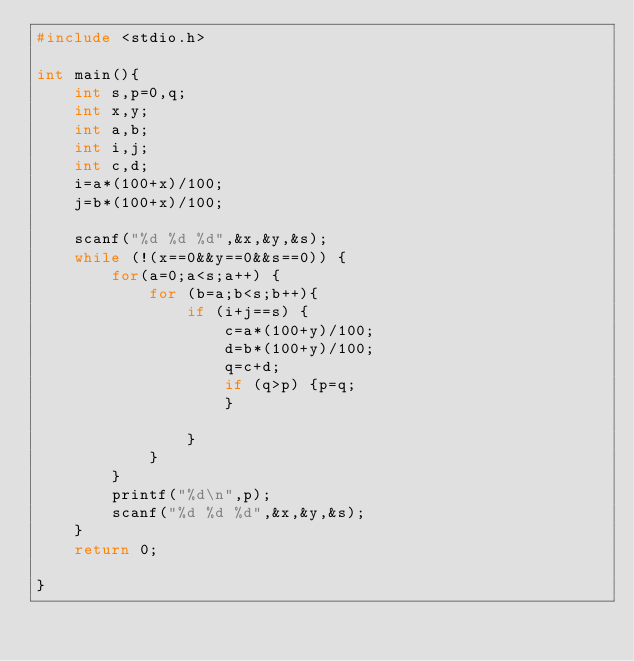<code> <loc_0><loc_0><loc_500><loc_500><_C_>#include <stdio.h>

int main(){
    int s,p=0,q;
    int x,y;
    int a,b;
    int i,j;
    int c,d;
    i=a*(100+x)/100;
    j=b*(100+x)/100;
  
    scanf("%d %d %d",&x,&y,&s);
    while (!(x==0&&y==0&&s==0)) {
        for(a=0;a<s;a++) {
            for (b=a;b<s;b++){
                if (i+j==s) {
                    c=a*(100+y)/100;
                    d=b*(100+y)/100;
                    q=c+d;
                    if (q>p) {p=q;
                    }
            
                }
            }
        }
        printf("%d\n",p);
        scanf("%d %d %d",&x,&y,&s);
    }
    return 0;

}</code> 